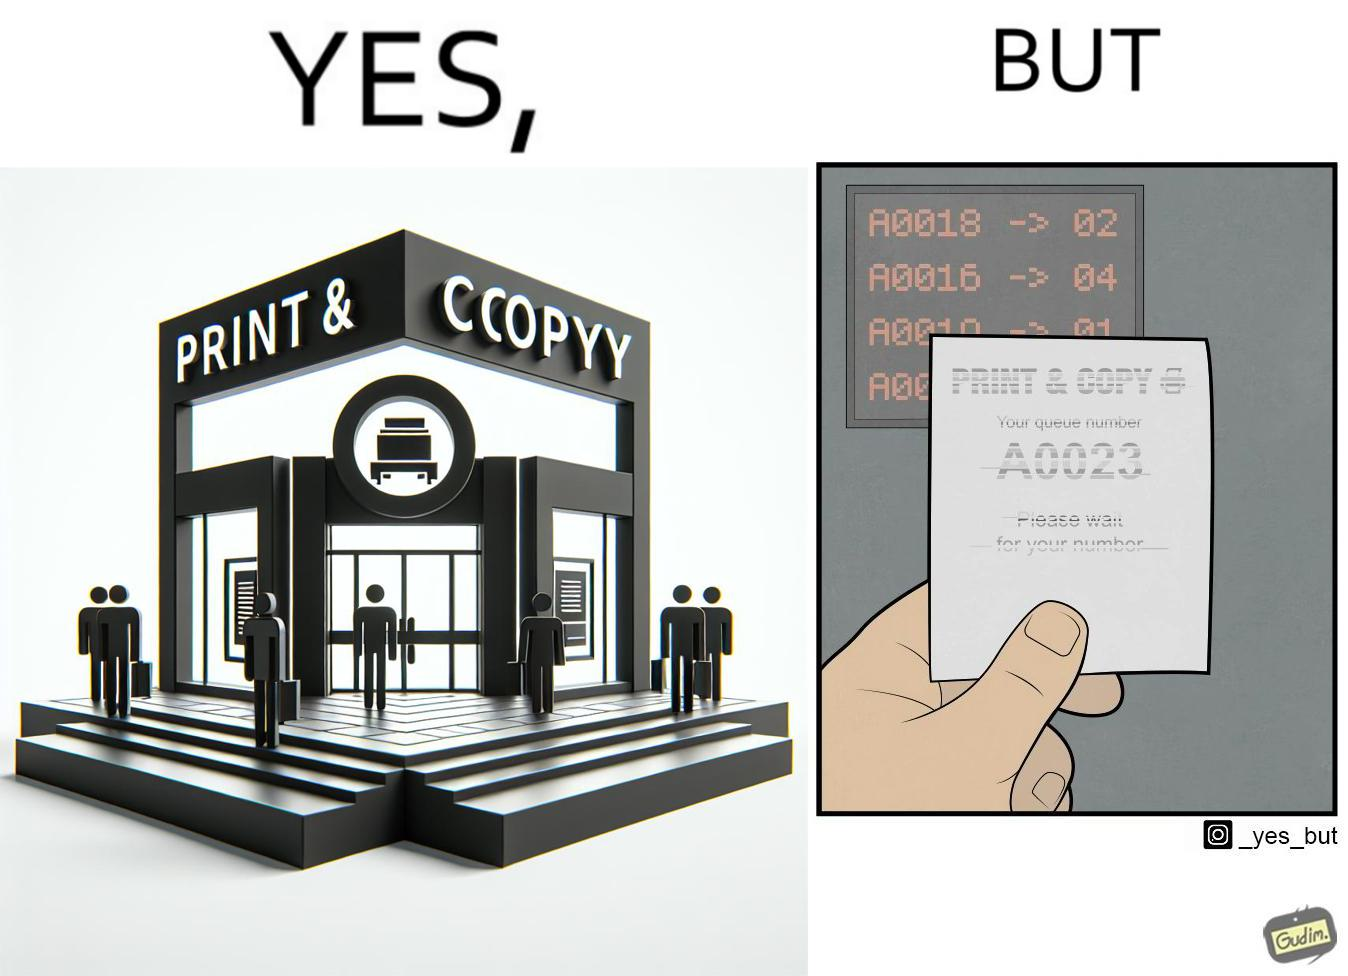Is this a satirical image? Yes, this image is satirical. 